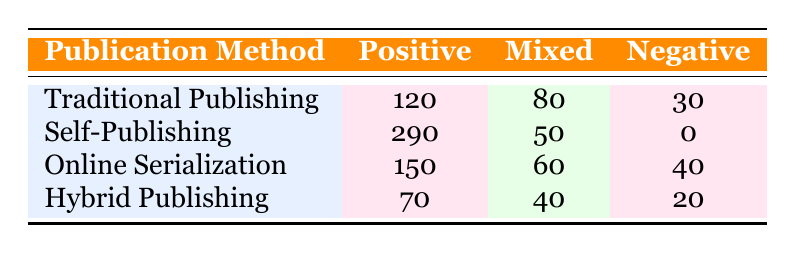What is the total count of positive reader reception for all publication methods? To find the total count of positive reader reception, we will add the counts for each publication method: Traditional Publishing (120) + Self-Publishing (290) + Online Serialization (150) + Hybrid Publishing (70) = 630.
Answer: 630 Which publication method has the lowest count for mixed reader reception? Looking at the mixed column, the counts are: Traditional Publishing (80), Self-Publishing (50), Online Serialization (60), and Hybrid Publishing (40). The lowest count is 40 for Hybrid Publishing.
Answer: Hybrid Publishing Is there a publication method that received no negative reader reception? Observing the negative column, we can see that Self-Publishing has a count of 0, while all other methods have positive counts. Hence, the statement is true.
Answer: Yes What is the difference in count of positive reader reception between Self-Publishing and Traditional Publishing? The counts are: Self-Publishing (290) and Traditional Publishing (120). The difference is calculated as 290 - 120 = 170.
Answer: 170 What is the average count of mixed reader reception across all publication methods? The mixed counts are: Traditional Publishing (80), Self-Publishing (50), Online Serialization (60), and Hybrid Publishing (40). We sum them up: 80 + 50 + 60 + 40 = 230. Then we divide by the number of methods (4): 230 / 4 = 57.5.
Answer: 57.5 Which genre in the table has the most positive reader reception, and how many counts does it have? We look at the positive counts: Traditional Publishing (120), Self-Publishing (290), Online Serialization (150), and Hybrid Publishing (70). The highest count is for Self-Publishing with 290.
Answer: Self-Publishing, 290 What is the total count of negative reader reception across all publication methods? We will add the negative counts: Traditional Publishing (30), Self-Publishing (0), Online Serialization (40), and Hybrid Publishing (20). The total is 30 + 0 + 40 + 20 = 90.
Answer: 90 